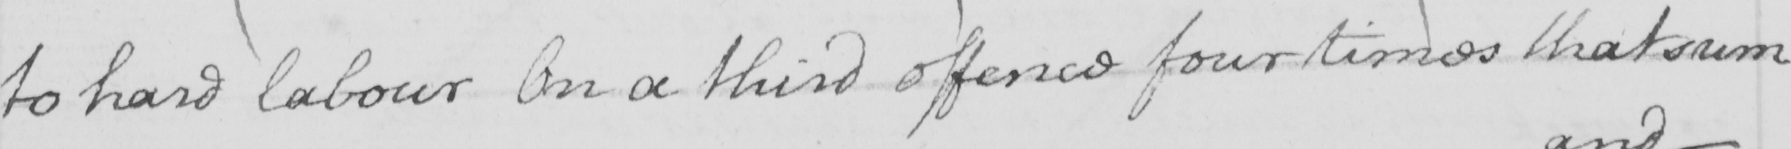What is written in this line of handwriting? to hard labour On a third offence four times that sum 